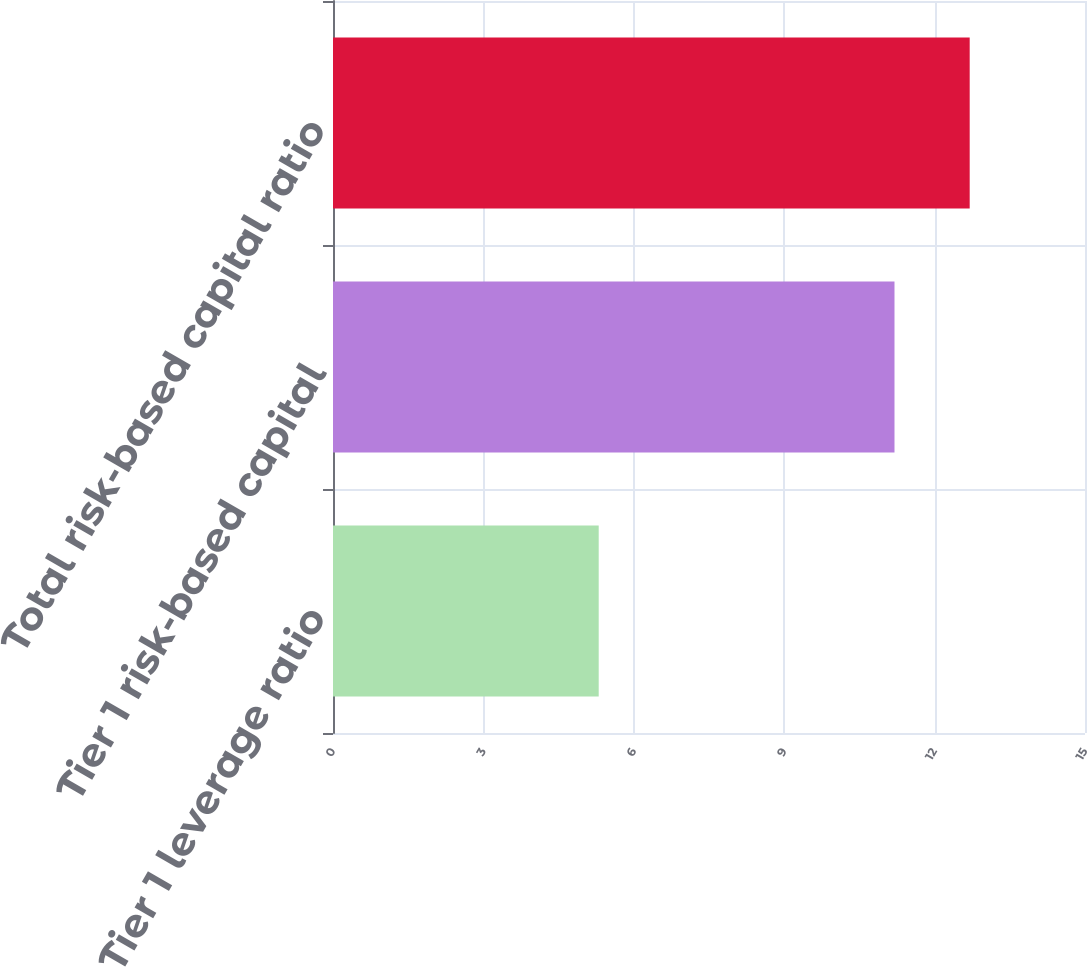Convert chart to OTSL. <chart><loc_0><loc_0><loc_500><loc_500><bar_chart><fcel>Tier 1 leverage ratio<fcel>Tier 1 risk-based capital<fcel>Total risk-based capital ratio<nl><fcel>5.3<fcel>11.2<fcel>12.7<nl></chart> 